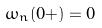Convert formula to latex. <formula><loc_0><loc_0><loc_500><loc_500>\omega _ { n } ( 0 + ) = 0</formula> 